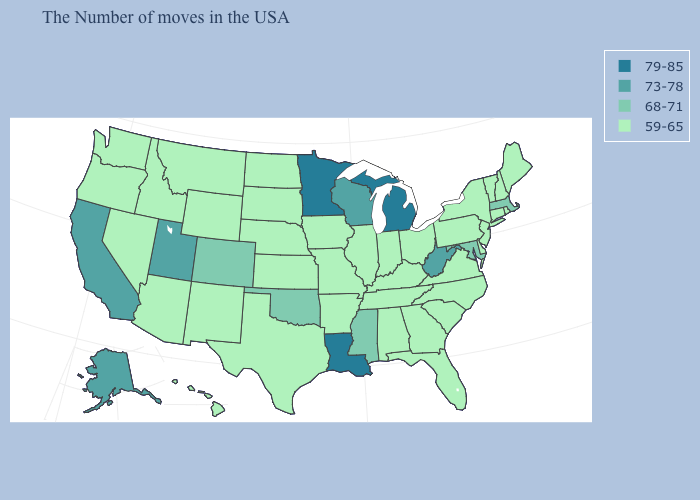Which states have the highest value in the USA?
Answer briefly. Michigan, Louisiana, Minnesota. What is the value of Nebraska?
Keep it brief. 59-65. What is the value of Louisiana?
Give a very brief answer. 79-85. Name the states that have a value in the range 68-71?
Give a very brief answer. Massachusetts, Maryland, Mississippi, Oklahoma, Colorado. Does the map have missing data?
Quick response, please. No. Name the states that have a value in the range 68-71?
Short answer required. Massachusetts, Maryland, Mississippi, Oklahoma, Colorado. Name the states that have a value in the range 68-71?
Write a very short answer. Massachusetts, Maryland, Mississippi, Oklahoma, Colorado. Does Washington have the highest value in the USA?
Concise answer only. No. Does Massachusetts have the lowest value in the Northeast?
Answer briefly. No. What is the value of Arizona?
Short answer required. 59-65. Does Virginia have the lowest value in the USA?
Short answer required. Yes. Which states hav the highest value in the South?
Keep it brief. Louisiana. Among the states that border Oregon , which have the highest value?
Answer briefly. California. Among the states that border Mississippi , does Louisiana have the lowest value?
Write a very short answer. No. What is the highest value in the USA?
Keep it brief. 79-85. 